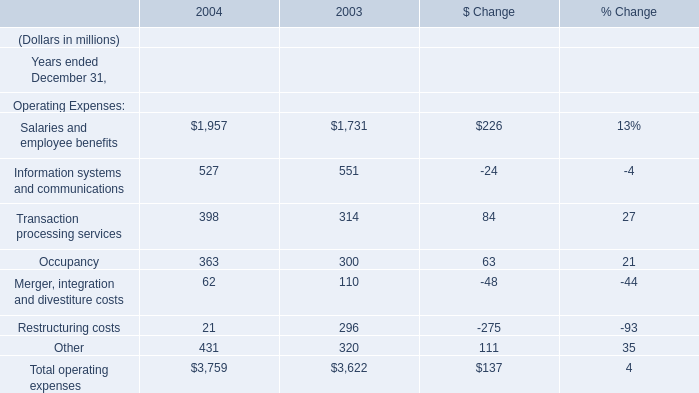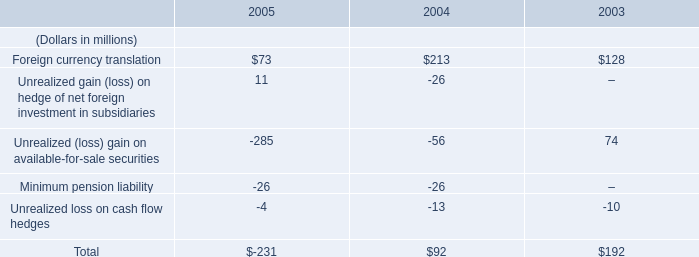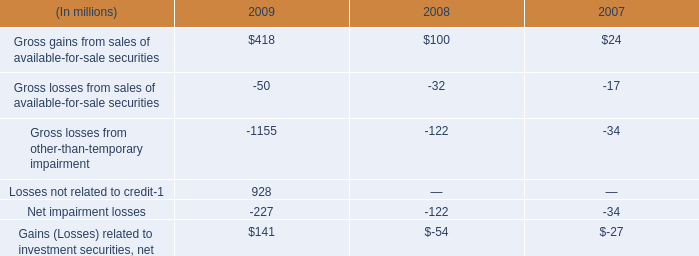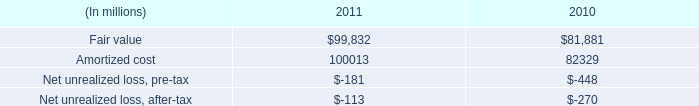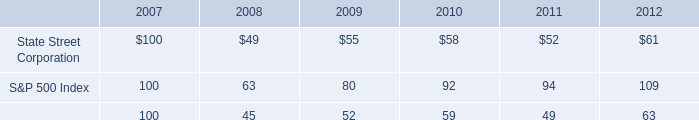what percent of the $ 227 million was associated with expected credit losses? 
Computations: (151 / 227)
Answer: 0.6652. 